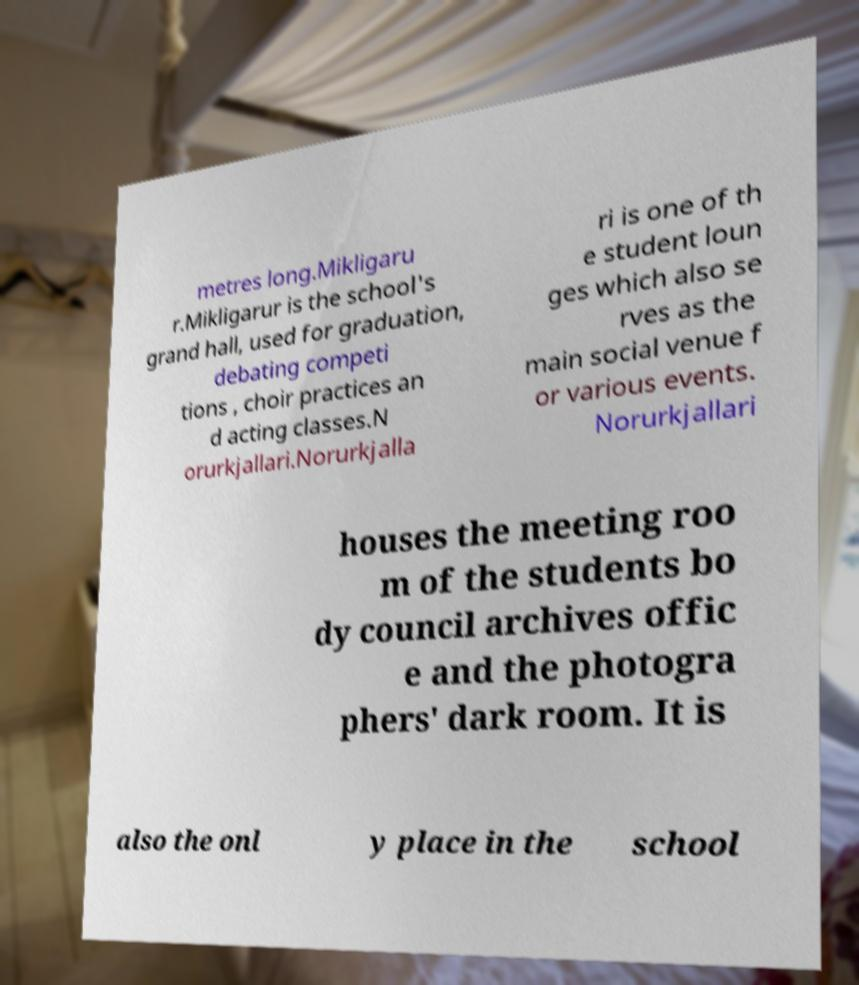Could you extract and type out the text from this image? metres long.Mikligaru r.Mikligarur is the school's grand hall, used for graduation, debating competi tions , choir practices an d acting classes.N orurkjallari.Norurkjalla ri is one of th e student loun ges which also se rves as the main social venue f or various events. Norurkjallari houses the meeting roo m of the students bo dy council archives offic e and the photogra phers' dark room. It is also the onl y place in the school 